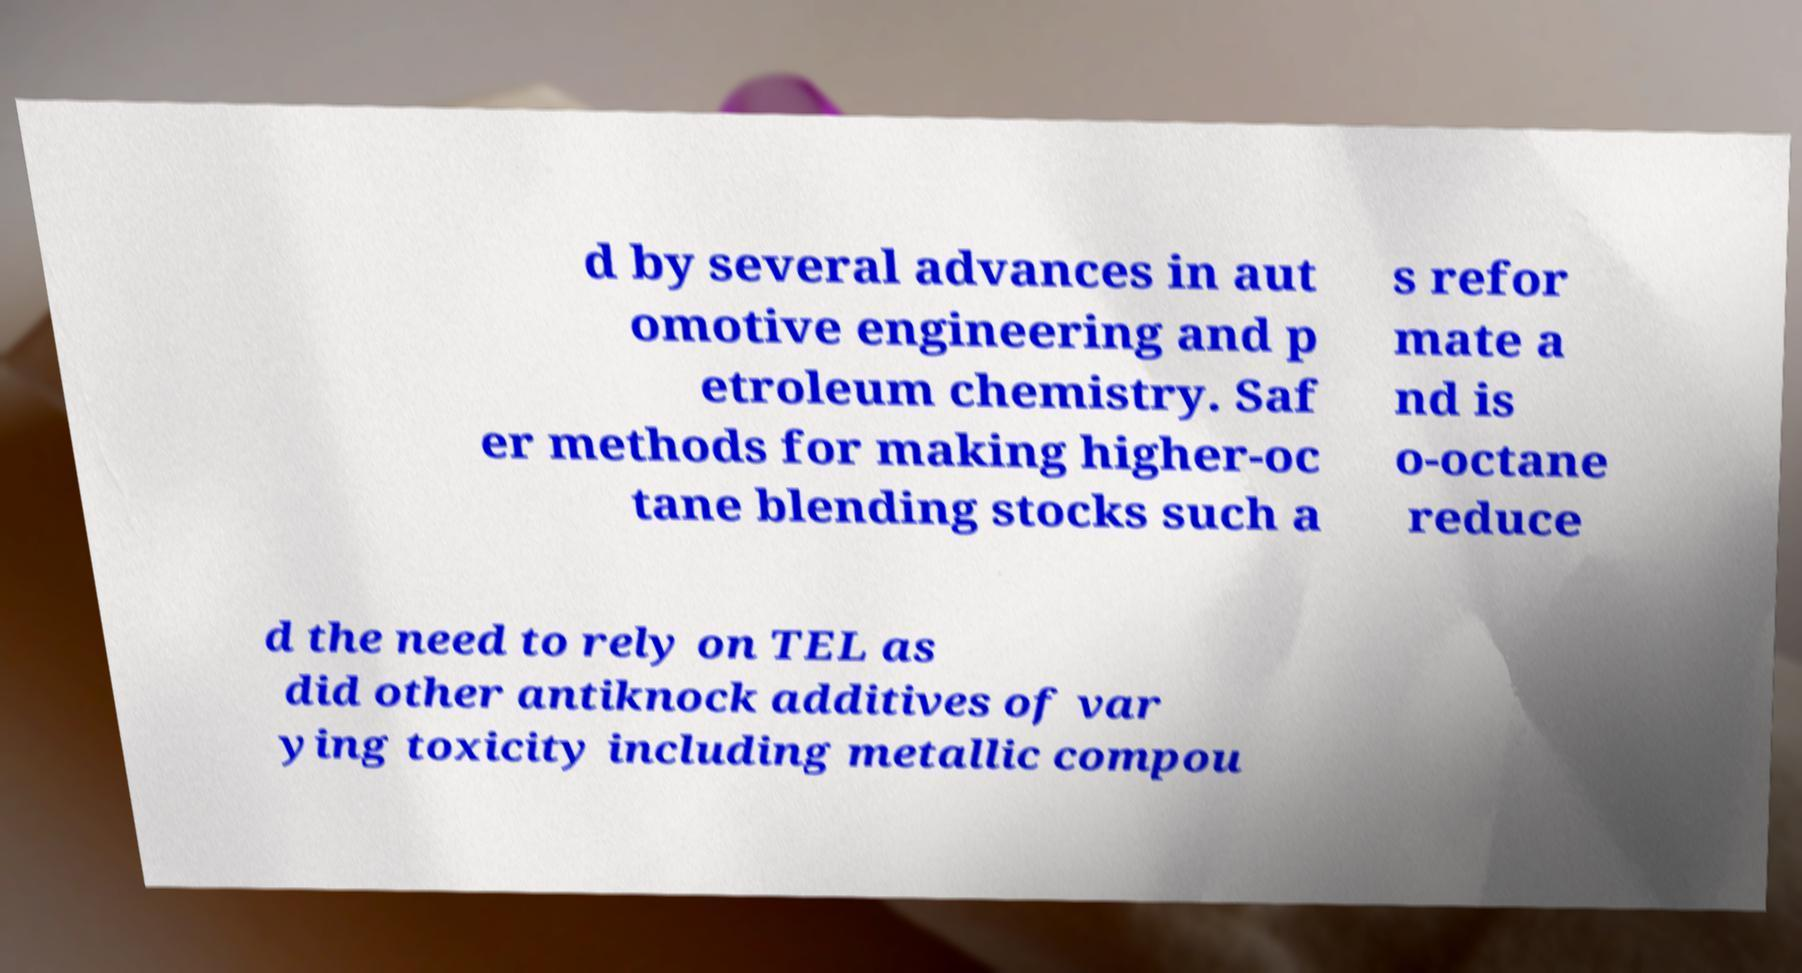Please identify and transcribe the text found in this image. d by several advances in aut omotive engineering and p etroleum chemistry. Saf er methods for making higher-oc tane blending stocks such a s refor mate a nd is o-octane reduce d the need to rely on TEL as did other antiknock additives of var ying toxicity including metallic compou 